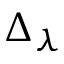Convert formula to latex. <formula><loc_0><loc_0><loc_500><loc_500>\Delta _ { \lambda }</formula> 